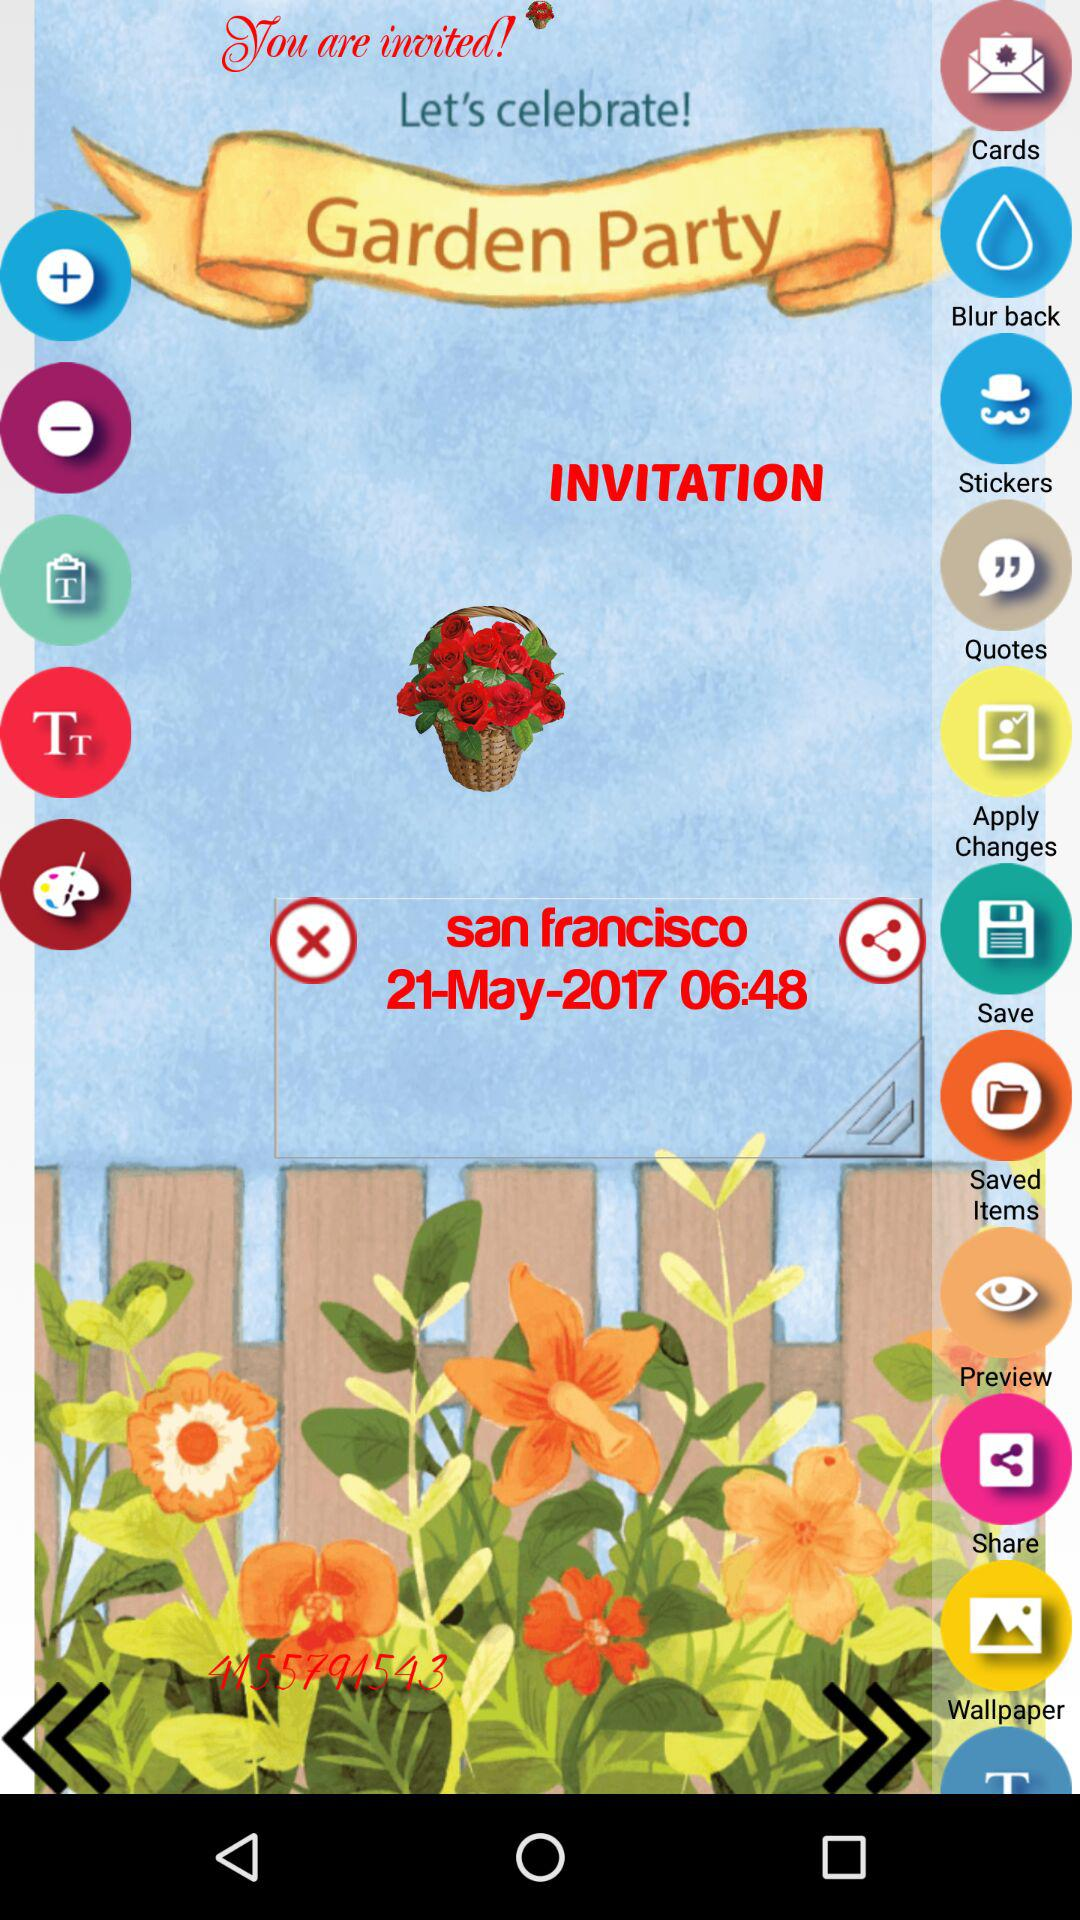What is the timing of the party? The timing of the party is 06:48. 